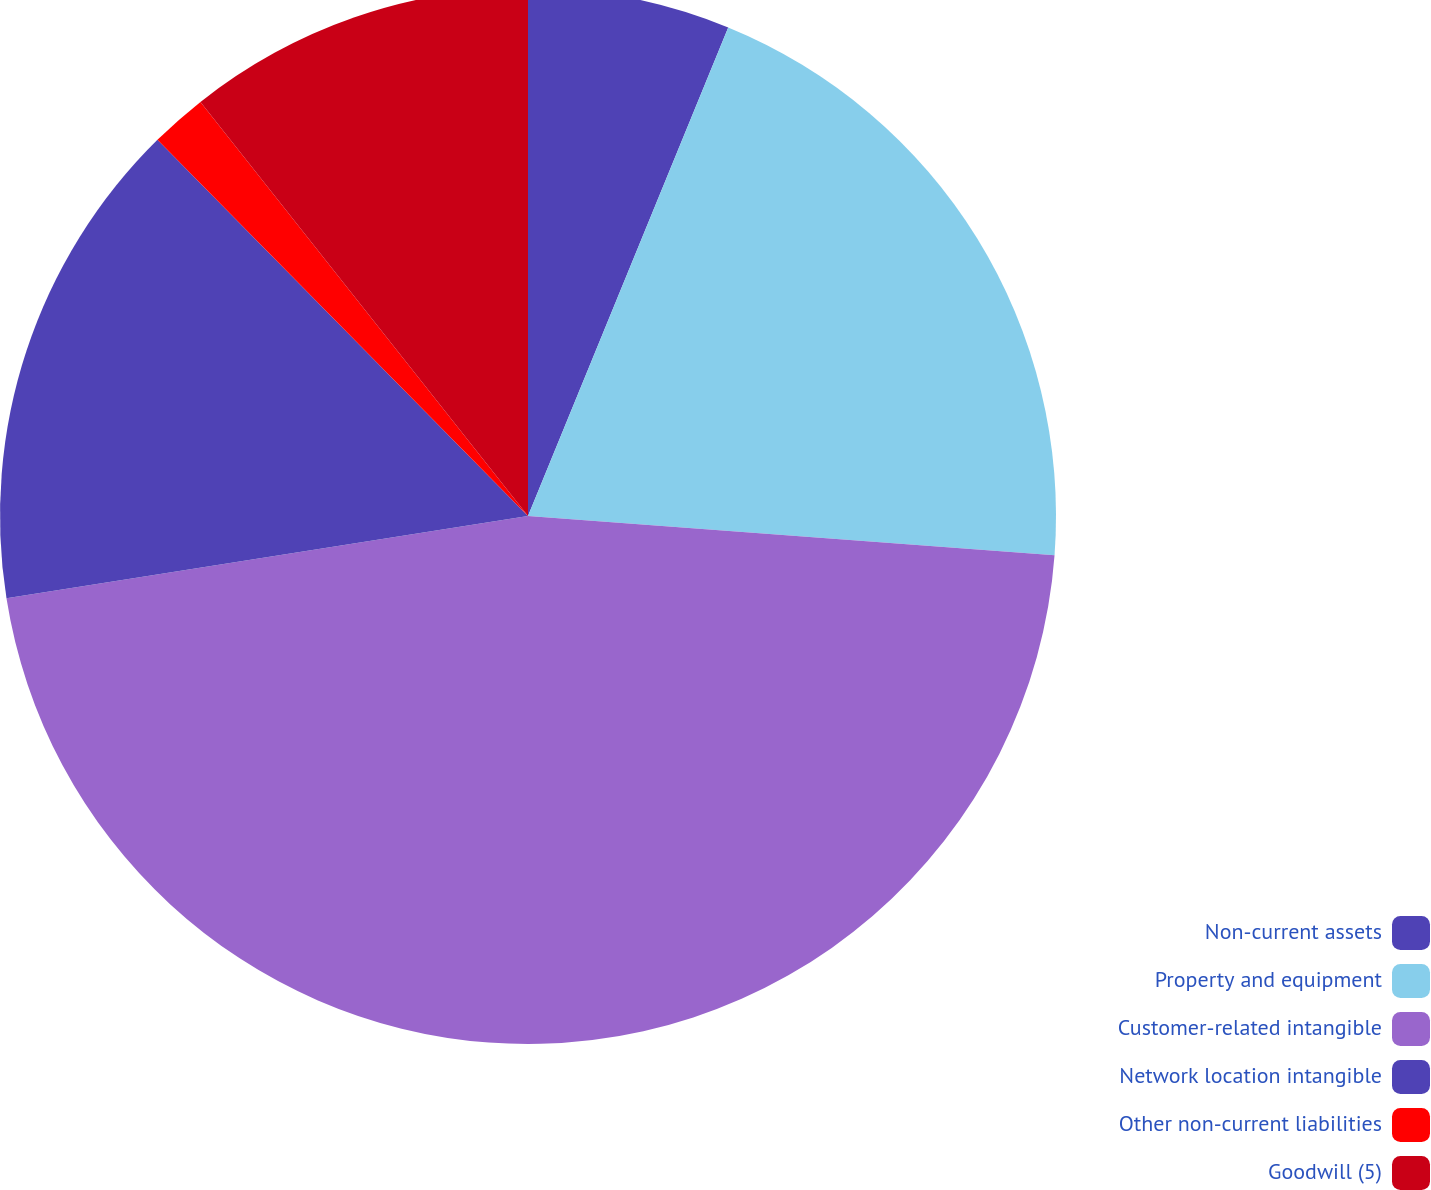Convert chart to OTSL. <chart><loc_0><loc_0><loc_500><loc_500><pie_chart><fcel>Non-current assets<fcel>Property and equipment<fcel>Customer-related intangible<fcel>Network location intangible<fcel>Other non-current liabilities<fcel>Goodwill (5)<nl><fcel>6.19%<fcel>19.99%<fcel>46.32%<fcel>15.11%<fcel>1.73%<fcel>10.65%<nl></chart> 